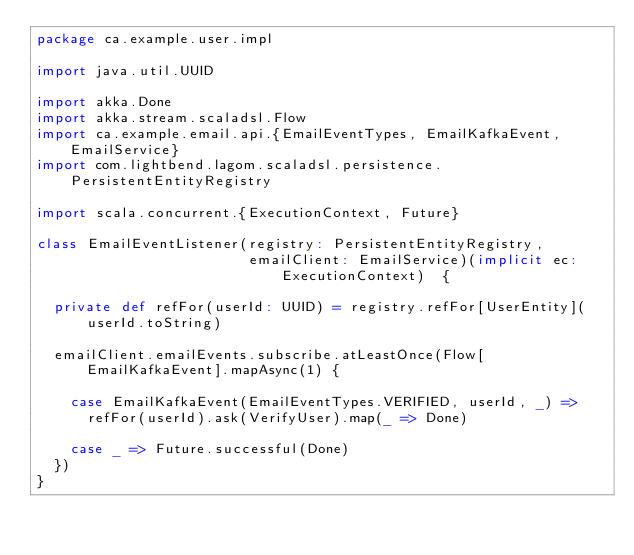Convert code to text. <code><loc_0><loc_0><loc_500><loc_500><_Scala_>package ca.example.user.impl

import java.util.UUID

import akka.Done
import akka.stream.scaladsl.Flow
import ca.example.email.api.{EmailEventTypes, EmailKafkaEvent, EmailService}
import com.lightbend.lagom.scaladsl.persistence.PersistentEntityRegistry

import scala.concurrent.{ExecutionContext, Future}

class EmailEventListener(registry: PersistentEntityRegistry,
                         emailClient: EmailService)(implicit ec: ExecutionContext)  {

  private def refFor(userId: UUID) = registry.refFor[UserEntity](userId.toString)

  emailClient.emailEvents.subscribe.atLeastOnce(Flow[EmailKafkaEvent].mapAsync(1) {

    case EmailKafkaEvent(EmailEventTypes.VERIFIED, userId, _) =>
      refFor(userId).ask(VerifyUser).map(_ => Done)

    case _ => Future.successful(Done)
  })
}

</code> 